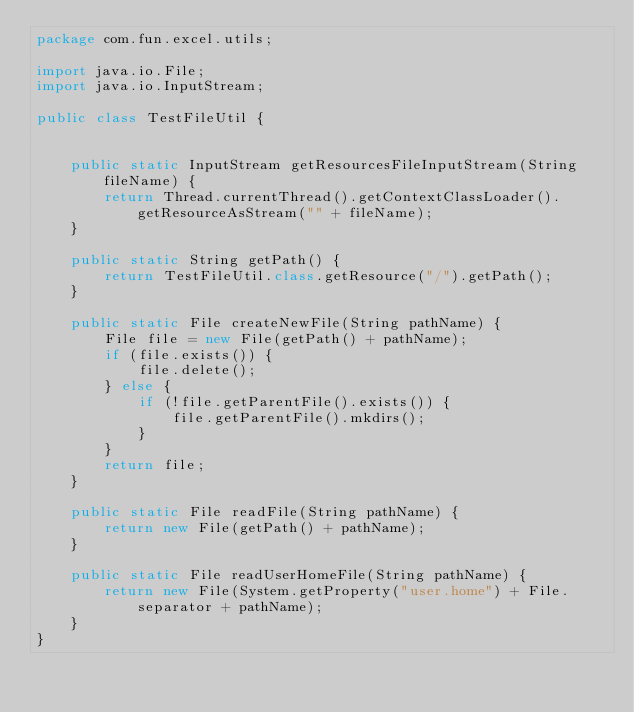<code> <loc_0><loc_0><loc_500><loc_500><_Java_>package com.fun.excel.utils;

import java.io.File;
import java.io.InputStream;

public class TestFileUtil {


    public static InputStream getResourcesFileInputStream(String fileName) {
        return Thread.currentThread().getContextClassLoader().getResourceAsStream("" + fileName);
    }

    public static String getPath() {
        return TestFileUtil.class.getResource("/").getPath();
    }

    public static File createNewFile(String pathName) {
        File file = new File(getPath() + pathName);
        if (file.exists()) {
            file.delete();
        } else {
            if (!file.getParentFile().exists()) {
                file.getParentFile().mkdirs();
            }
        }
        return file;
    }

    public static File readFile(String pathName) {
        return new File(getPath() + pathName);
    }

    public static File readUserHomeFile(String pathName) {
        return new File(System.getProperty("user.home") + File.separator + pathName);
    }
}
</code> 